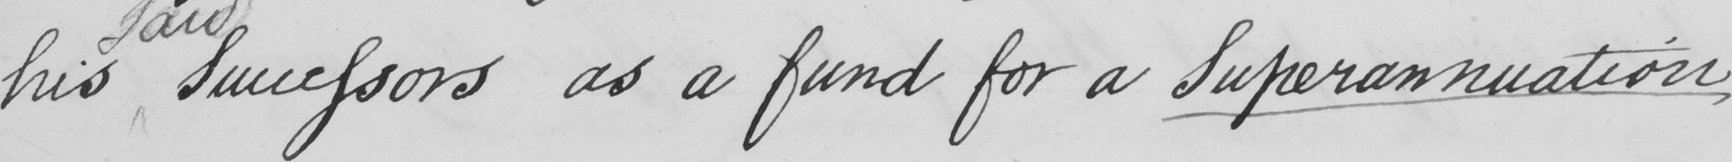Please provide the text content of this handwritten line. his Successors as a fund for a Superannuation 